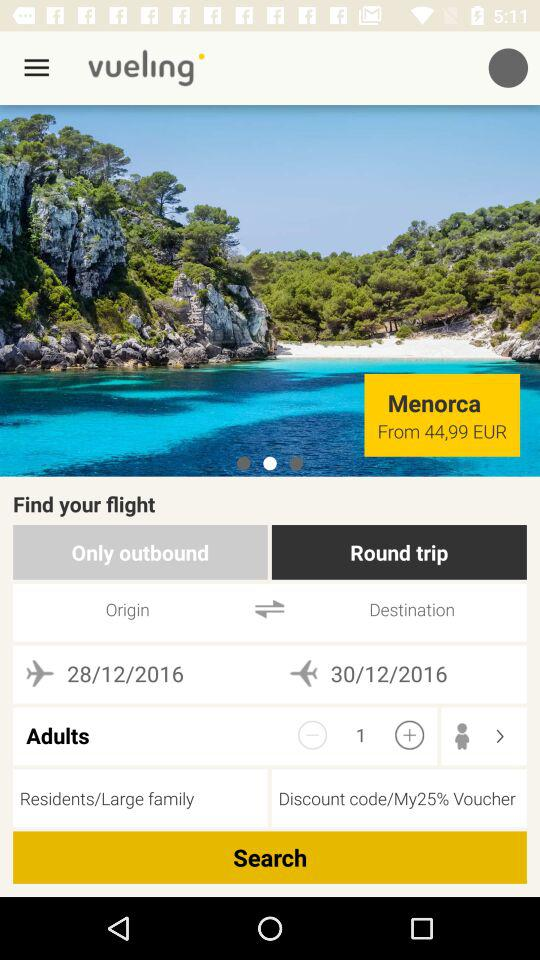For which date is the flight being booked? The flight is being booked for December 28, 2016 and December 30, 2016. 